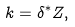Convert formula to latex. <formula><loc_0><loc_0><loc_500><loc_500>k = \delta ^ { * } Z ,</formula> 